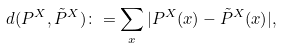Convert formula to latex. <formula><loc_0><loc_0><loc_500><loc_500>d ( P ^ { X } , \tilde { P } ^ { X } ) \colon = \sum _ { x } | P ^ { X } ( x ) - \tilde { P } ^ { X } ( x ) | ,</formula> 